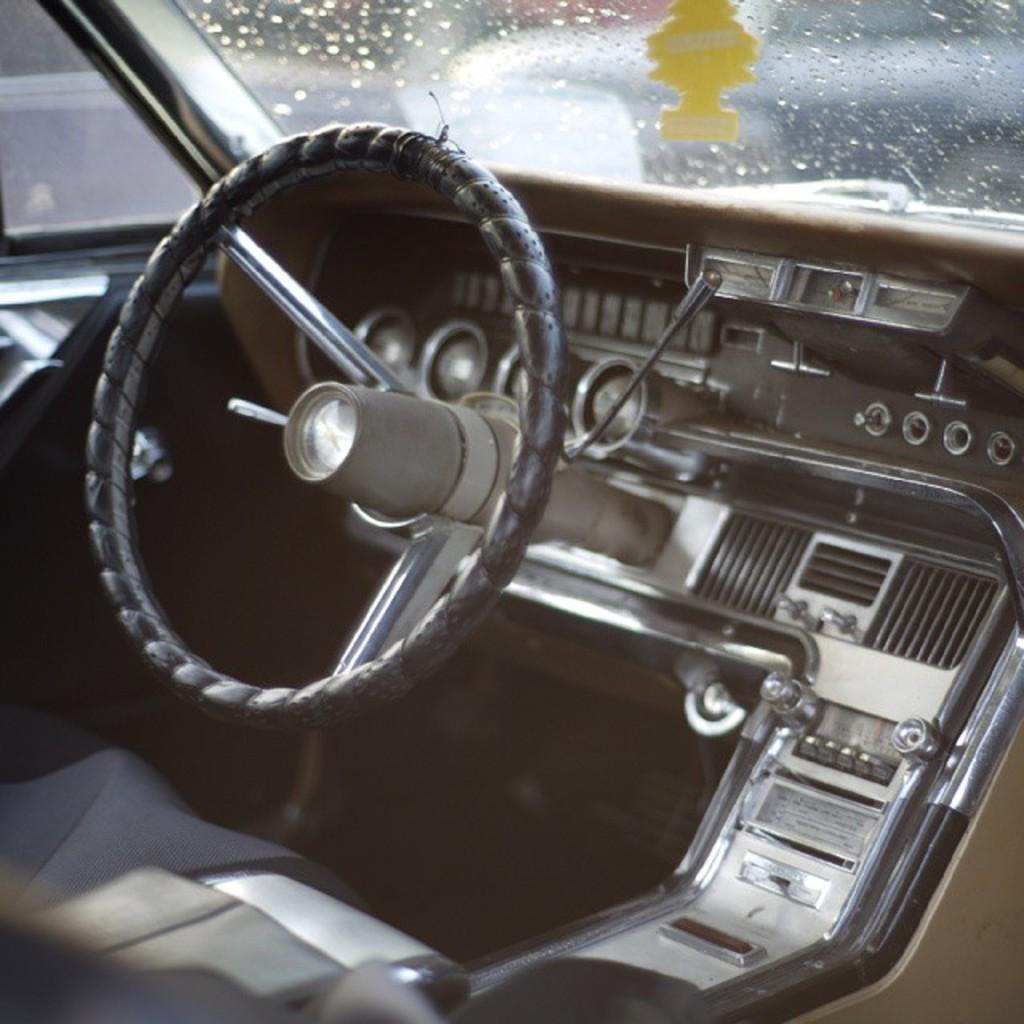Describe this image in one or two sentences. In this image I can see the inner part of the vehicle and I can see a steering, and I can see blurred background. 